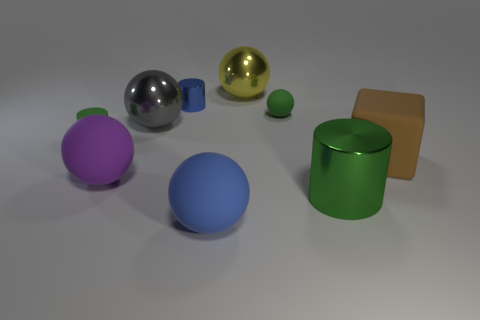There is a big metallic ball that is on the right side of the large blue thing that is in front of the green matte object that is behind the gray metal sphere; what is its color?
Your response must be concise. Yellow. What is the shape of the blue shiny thing?
Your answer should be very brief. Cylinder. There is a big metal cylinder; is it the same color as the big matte sphere on the left side of the gray metal thing?
Your answer should be compact. No. Are there an equal number of brown matte things to the right of the large brown block and large red rubber things?
Make the answer very short. Yes. What number of gray spheres have the same size as the block?
Make the answer very short. 1. There is another object that is the same color as the small metal thing; what is its shape?
Provide a succinct answer. Sphere. Is there a big ball?
Your answer should be compact. Yes. There is a green matte thing that is to the right of the tiny green rubber cylinder; is it the same shape as the blue object that is in front of the brown cube?
Make the answer very short. Yes. How many tiny things are either red rubber objects or matte cubes?
Ensure brevity in your answer.  0. There is a blue object that is the same material as the big cube; what shape is it?
Ensure brevity in your answer.  Sphere. 